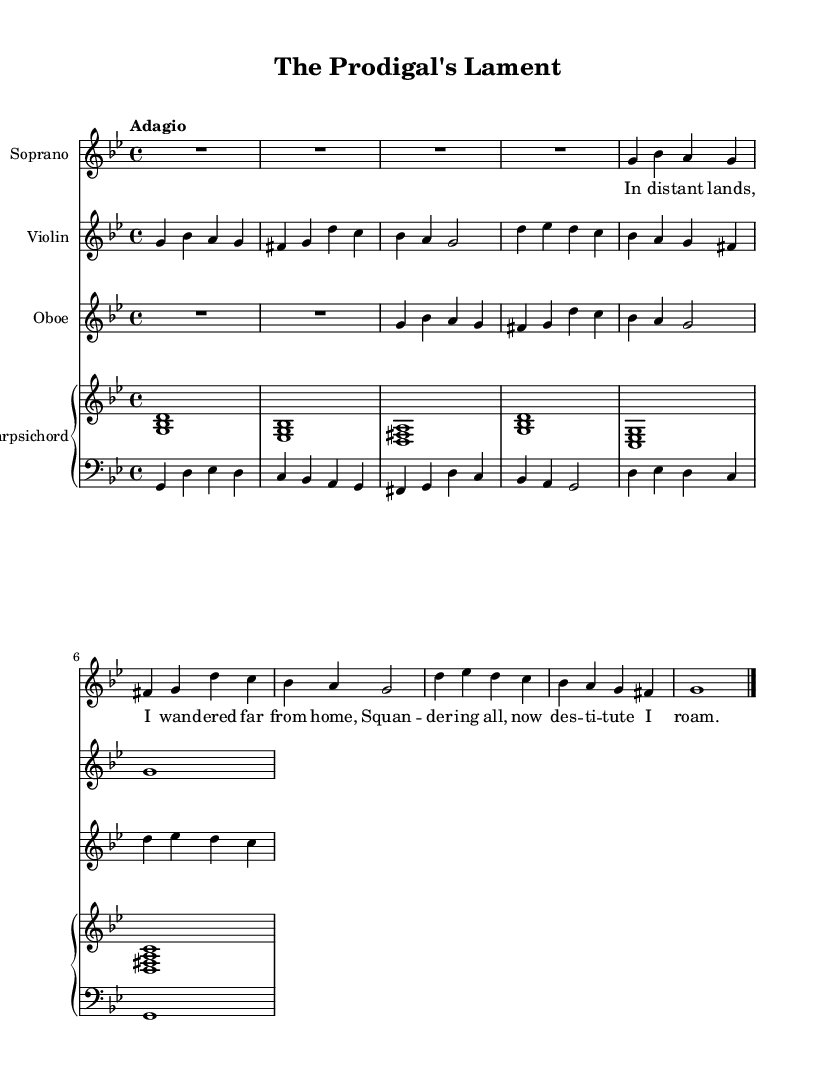What is the key signature of this music? The key signature at the beginning of the score indicates two flats (B♭ and E♭), which defines the musical key.
Answer: G minor What is the time signature of this music? The time signature displayed at the beginning shows a 4/4, meaning there are four beats in each measure, and the quarter note gets one beat.
Answer: 4/4 What is the tempo marking indicated for this piece? The tempo marking specified in the score is "Adagio," indicating a slow and leisurely pace for the performance of the piece.
Answer: Adagio How many voices/instruments are used in this composition? The score lists four distinct staves corresponding to different instruments: Soprano, Violin, Oboe, and Harpsichord (with Cello). Counting these gives the total number of voices/instruments.
Answer: Four What narrative element is present in the text of the piece? The text reflects a personal confession and longing for home, typical of a narrative describing a repentant character's feelings and situation, suggesting a theme of loss and redemption.
Answer: Personal confession Which instrument plays the bass line in this composition? The cello part is typically responsible for the bass line in Baroque compositions, providing harmonic support alongside the keyboard instrument (harpsichord).
Answer: Cello What is the overall mood conveyed by the music based on the tempo and text? The combination of the slow tempo (Adagio) and the text expressing lamentation indicates a somber and reflective mood, suitable for expressing sorrow or longing.
Answer: Somber 